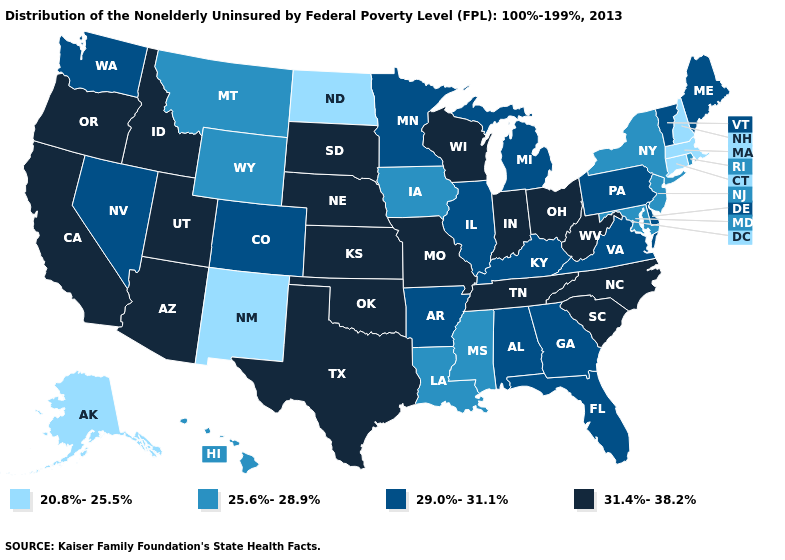What is the value of North Dakota?
Be succinct. 20.8%-25.5%. Does Iowa have the highest value in the USA?
Give a very brief answer. No. Name the states that have a value in the range 31.4%-38.2%?
Answer briefly. Arizona, California, Idaho, Indiana, Kansas, Missouri, Nebraska, North Carolina, Ohio, Oklahoma, Oregon, South Carolina, South Dakota, Tennessee, Texas, Utah, West Virginia, Wisconsin. What is the value of Nevada?
Concise answer only. 29.0%-31.1%. Which states have the lowest value in the South?
Short answer required. Louisiana, Maryland, Mississippi. What is the value of Alaska?
Keep it brief. 20.8%-25.5%. What is the lowest value in the USA?
Keep it brief. 20.8%-25.5%. Among the states that border Idaho , which have the lowest value?
Keep it brief. Montana, Wyoming. What is the highest value in the South ?
Short answer required. 31.4%-38.2%. What is the value of Maryland?
Be succinct. 25.6%-28.9%. What is the highest value in the MidWest ?
Short answer required. 31.4%-38.2%. Name the states that have a value in the range 20.8%-25.5%?
Quick response, please. Alaska, Connecticut, Massachusetts, New Hampshire, New Mexico, North Dakota. How many symbols are there in the legend?
Give a very brief answer. 4. Among the states that border South Carolina , which have the highest value?
Answer briefly. North Carolina. 